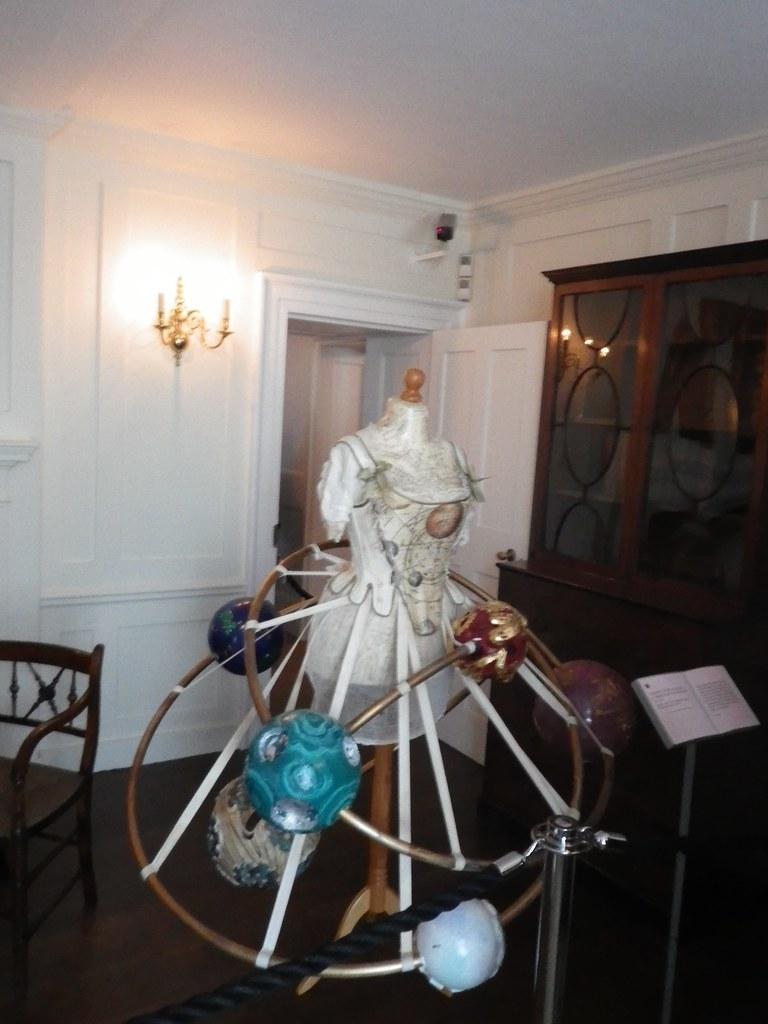Describe this image in one or two sentences. In the center of the image, we can see a mannequin and there are stands and some decors items and we can see a book. In the background, there are window, a door, a cctv camera and we can see some lights and there is a wall and a chair and we can see a rope. 